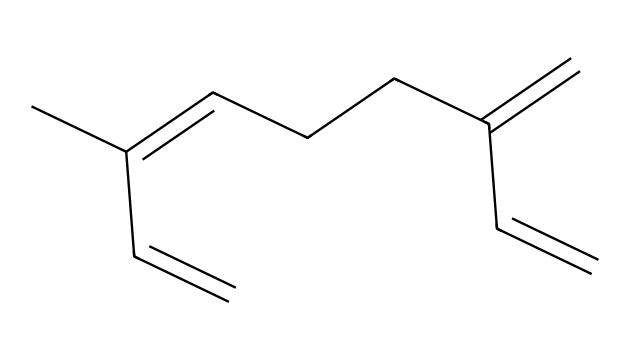What is the molecular formula for myrcene? To determine the molecular formula, we need to count the number of carbon (C) and hydrogen (H) atoms in the structure represented by the SMILES. Myrcene has a chain of 10 carbon atoms and 16 hydrogen atoms.
Answer: C10H16 How many double bonds are present in myrcene? By examining the structure and the SMILES representation, we can identify the double bonds. Myrcene contains three double bonds, as indicated by the '=' symbols in the SMILES.
Answer: 3 What type of compound is myrcene classified as? Analyzing the structure, we find the presence of a hydrocarbon with a specific arrangement of double bonds. Since it is a terpene with the structure primarily composed of carbon and hydrogen, it is classified as a terpene.
Answer: terpene What functional group is primarily featured in myrcene? In myrcene's structure, the crucial feature is the presence of carbon-carbon double bonds, which qualify it as an alkene. Therefore, the primary functional group is the alkene group.
Answer: alkene Which part of myrcene contributes to its relaxing effects? Myrcene has been studied for its relaxing properties, largely due to its structural characteristics; specifically, the arrangement and number of double bonds, which may affect the interaction with cannabinoid receptors.
Answer: double bonds 